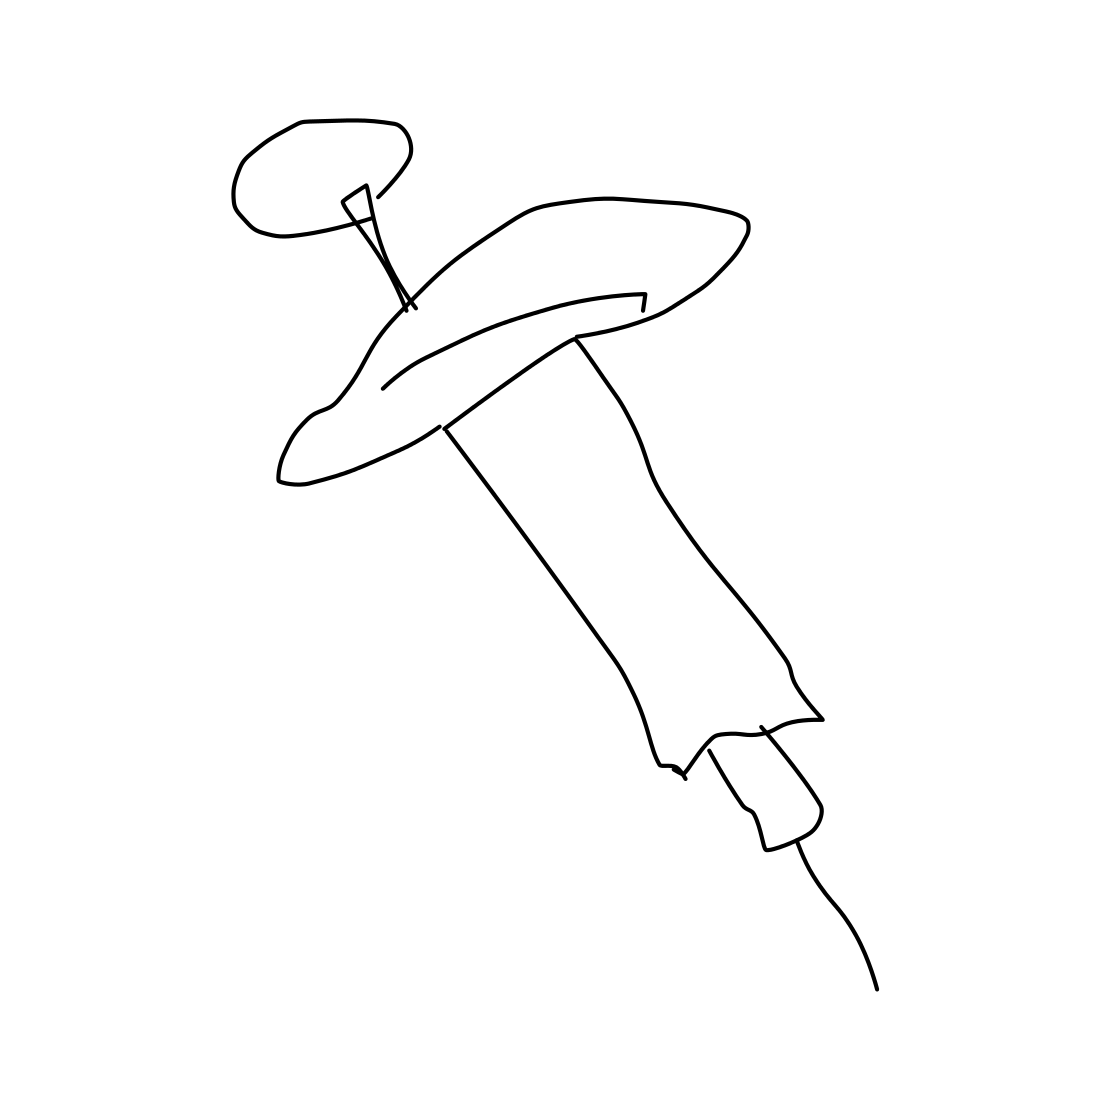Is this type of syringe reusable or disposable? Based on the image, it looks like a standard disposable syringe that is intended for one-time use to ensure sterility and prevent cross-contamination. 